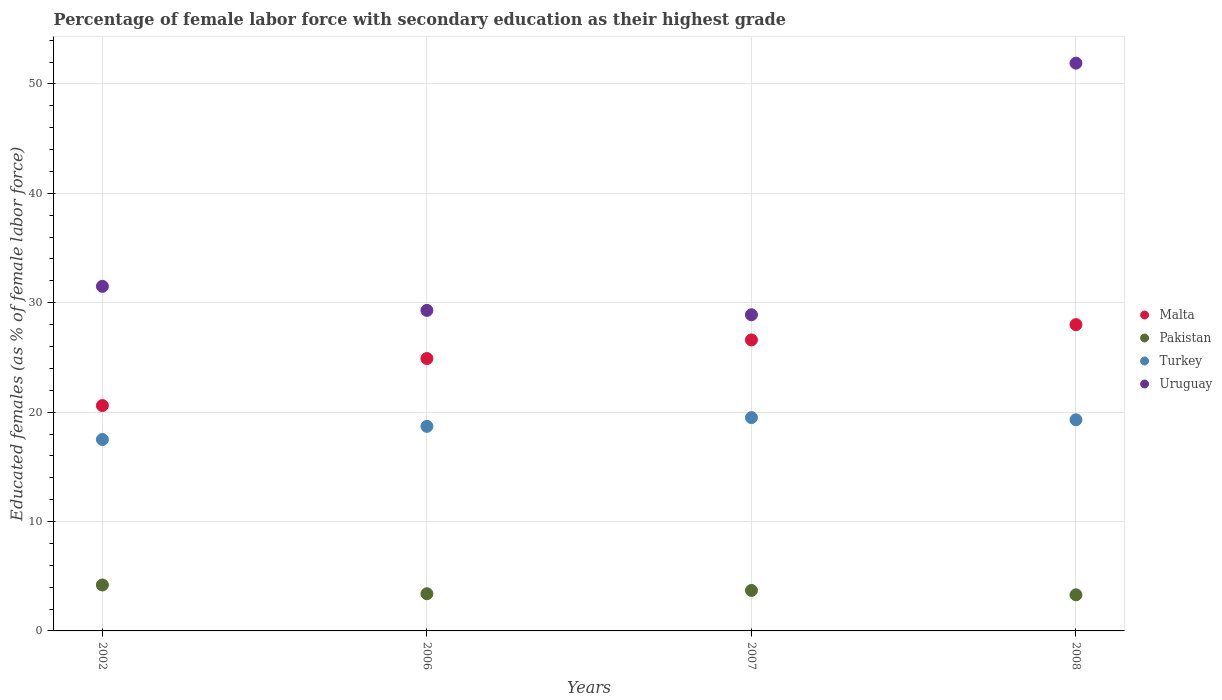How many different coloured dotlines are there?
Your answer should be compact. 4. Is the number of dotlines equal to the number of legend labels?
Provide a short and direct response. Yes. What is the percentage of female labor force with secondary education in Pakistan in 2008?
Provide a short and direct response. 3.3. Across all years, what is the maximum percentage of female labor force with secondary education in Pakistan?
Provide a succinct answer. 4.2. Across all years, what is the minimum percentage of female labor force with secondary education in Uruguay?
Provide a short and direct response. 28.9. In which year was the percentage of female labor force with secondary education in Turkey minimum?
Your answer should be very brief. 2002. What is the total percentage of female labor force with secondary education in Pakistan in the graph?
Your response must be concise. 14.6. What is the difference between the percentage of female labor force with secondary education in Uruguay in 2002 and that in 2007?
Give a very brief answer. 2.6. What is the difference between the percentage of female labor force with secondary education in Malta in 2008 and the percentage of female labor force with secondary education in Turkey in 2007?
Give a very brief answer. 8.5. What is the average percentage of female labor force with secondary education in Malta per year?
Keep it short and to the point. 25.03. In the year 2006, what is the difference between the percentage of female labor force with secondary education in Malta and percentage of female labor force with secondary education in Uruguay?
Provide a succinct answer. -4.4. What is the ratio of the percentage of female labor force with secondary education in Turkey in 2002 to that in 2006?
Keep it short and to the point. 0.94. What is the difference between the highest and the second highest percentage of female labor force with secondary education in Pakistan?
Provide a succinct answer. 0.5. Is the sum of the percentage of female labor force with secondary education in Malta in 2002 and 2006 greater than the maximum percentage of female labor force with secondary education in Uruguay across all years?
Your answer should be very brief. No. Is it the case that in every year, the sum of the percentage of female labor force with secondary education in Turkey and percentage of female labor force with secondary education in Malta  is greater than the sum of percentage of female labor force with secondary education in Pakistan and percentage of female labor force with secondary education in Uruguay?
Ensure brevity in your answer.  No. Is it the case that in every year, the sum of the percentage of female labor force with secondary education in Pakistan and percentage of female labor force with secondary education in Uruguay  is greater than the percentage of female labor force with secondary education in Malta?
Provide a short and direct response. Yes. Does the percentage of female labor force with secondary education in Turkey monotonically increase over the years?
Ensure brevity in your answer.  No. Is the percentage of female labor force with secondary education in Turkey strictly less than the percentage of female labor force with secondary education in Malta over the years?
Make the answer very short. Yes. Does the graph contain any zero values?
Make the answer very short. No. Where does the legend appear in the graph?
Provide a succinct answer. Center right. How many legend labels are there?
Give a very brief answer. 4. How are the legend labels stacked?
Your answer should be very brief. Vertical. What is the title of the graph?
Offer a very short reply. Percentage of female labor force with secondary education as their highest grade. What is the label or title of the Y-axis?
Provide a succinct answer. Educated females (as % of female labor force). What is the Educated females (as % of female labor force) of Malta in 2002?
Your answer should be very brief. 20.6. What is the Educated females (as % of female labor force) in Pakistan in 2002?
Provide a short and direct response. 4.2. What is the Educated females (as % of female labor force) of Uruguay in 2002?
Keep it short and to the point. 31.5. What is the Educated females (as % of female labor force) in Malta in 2006?
Your answer should be compact. 24.9. What is the Educated females (as % of female labor force) in Pakistan in 2006?
Provide a short and direct response. 3.4. What is the Educated females (as % of female labor force) in Turkey in 2006?
Provide a short and direct response. 18.7. What is the Educated females (as % of female labor force) of Uruguay in 2006?
Give a very brief answer. 29.3. What is the Educated females (as % of female labor force) in Malta in 2007?
Your answer should be compact. 26.6. What is the Educated females (as % of female labor force) in Pakistan in 2007?
Give a very brief answer. 3.7. What is the Educated females (as % of female labor force) in Turkey in 2007?
Keep it short and to the point. 19.5. What is the Educated females (as % of female labor force) in Uruguay in 2007?
Make the answer very short. 28.9. What is the Educated females (as % of female labor force) of Pakistan in 2008?
Keep it short and to the point. 3.3. What is the Educated females (as % of female labor force) of Turkey in 2008?
Your response must be concise. 19.3. What is the Educated females (as % of female labor force) of Uruguay in 2008?
Provide a short and direct response. 51.9. Across all years, what is the maximum Educated females (as % of female labor force) of Malta?
Make the answer very short. 28. Across all years, what is the maximum Educated females (as % of female labor force) in Pakistan?
Offer a terse response. 4.2. Across all years, what is the maximum Educated females (as % of female labor force) in Uruguay?
Make the answer very short. 51.9. Across all years, what is the minimum Educated females (as % of female labor force) in Malta?
Your answer should be very brief. 20.6. Across all years, what is the minimum Educated females (as % of female labor force) in Pakistan?
Ensure brevity in your answer.  3.3. Across all years, what is the minimum Educated females (as % of female labor force) in Turkey?
Your answer should be compact. 17.5. Across all years, what is the minimum Educated females (as % of female labor force) of Uruguay?
Your answer should be compact. 28.9. What is the total Educated females (as % of female labor force) of Malta in the graph?
Give a very brief answer. 100.1. What is the total Educated females (as % of female labor force) in Turkey in the graph?
Your answer should be very brief. 75. What is the total Educated females (as % of female labor force) in Uruguay in the graph?
Offer a very short reply. 141.6. What is the difference between the Educated females (as % of female labor force) in Malta in 2002 and that in 2006?
Keep it short and to the point. -4.3. What is the difference between the Educated females (as % of female labor force) of Pakistan in 2002 and that in 2006?
Provide a short and direct response. 0.8. What is the difference between the Educated females (as % of female labor force) of Turkey in 2002 and that in 2006?
Your answer should be compact. -1.2. What is the difference between the Educated females (as % of female labor force) of Uruguay in 2002 and that in 2006?
Your answer should be very brief. 2.2. What is the difference between the Educated females (as % of female labor force) of Pakistan in 2002 and that in 2007?
Your answer should be compact. 0.5. What is the difference between the Educated females (as % of female labor force) of Uruguay in 2002 and that in 2007?
Your response must be concise. 2.6. What is the difference between the Educated females (as % of female labor force) in Malta in 2002 and that in 2008?
Keep it short and to the point. -7.4. What is the difference between the Educated females (as % of female labor force) in Turkey in 2002 and that in 2008?
Offer a very short reply. -1.8. What is the difference between the Educated females (as % of female labor force) of Uruguay in 2002 and that in 2008?
Offer a very short reply. -20.4. What is the difference between the Educated females (as % of female labor force) of Malta in 2006 and that in 2007?
Ensure brevity in your answer.  -1.7. What is the difference between the Educated females (as % of female labor force) of Pakistan in 2006 and that in 2007?
Ensure brevity in your answer.  -0.3. What is the difference between the Educated females (as % of female labor force) of Uruguay in 2006 and that in 2007?
Offer a very short reply. 0.4. What is the difference between the Educated females (as % of female labor force) in Malta in 2006 and that in 2008?
Keep it short and to the point. -3.1. What is the difference between the Educated females (as % of female labor force) in Turkey in 2006 and that in 2008?
Provide a short and direct response. -0.6. What is the difference between the Educated females (as % of female labor force) of Uruguay in 2006 and that in 2008?
Make the answer very short. -22.6. What is the difference between the Educated females (as % of female labor force) in Malta in 2007 and that in 2008?
Keep it short and to the point. -1.4. What is the difference between the Educated females (as % of female labor force) in Malta in 2002 and the Educated females (as % of female labor force) in Turkey in 2006?
Offer a very short reply. 1.9. What is the difference between the Educated females (as % of female labor force) of Pakistan in 2002 and the Educated females (as % of female labor force) of Uruguay in 2006?
Provide a succinct answer. -25.1. What is the difference between the Educated females (as % of female labor force) in Turkey in 2002 and the Educated females (as % of female labor force) in Uruguay in 2006?
Offer a terse response. -11.8. What is the difference between the Educated females (as % of female labor force) of Malta in 2002 and the Educated females (as % of female labor force) of Pakistan in 2007?
Your response must be concise. 16.9. What is the difference between the Educated females (as % of female labor force) in Pakistan in 2002 and the Educated females (as % of female labor force) in Turkey in 2007?
Your response must be concise. -15.3. What is the difference between the Educated females (as % of female labor force) in Pakistan in 2002 and the Educated females (as % of female labor force) in Uruguay in 2007?
Offer a very short reply. -24.7. What is the difference between the Educated females (as % of female labor force) in Turkey in 2002 and the Educated females (as % of female labor force) in Uruguay in 2007?
Provide a succinct answer. -11.4. What is the difference between the Educated females (as % of female labor force) in Malta in 2002 and the Educated females (as % of female labor force) in Pakistan in 2008?
Your answer should be compact. 17.3. What is the difference between the Educated females (as % of female labor force) of Malta in 2002 and the Educated females (as % of female labor force) of Turkey in 2008?
Keep it short and to the point. 1.3. What is the difference between the Educated females (as % of female labor force) of Malta in 2002 and the Educated females (as % of female labor force) of Uruguay in 2008?
Give a very brief answer. -31.3. What is the difference between the Educated females (as % of female labor force) of Pakistan in 2002 and the Educated females (as % of female labor force) of Turkey in 2008?
Keep it short and to the point. -15.1. What is the difference between the Educated females (as % of female labor force) of Pakistan in 2002 and the Educated females (as % of female labor force) of Uruguay in 2008?
Offer a terse response. -47.7. What is the difference between the Educated females (as % of female labor force) in Turkey in 2002 and the Educated females (as % of female labor force) in Uruguay in 2008?
Offer a terse response. -34.4. What is the difference between the Educated females (as % of female labor force) of Malta in 2006 and the Educated females (as % of female labor force) of Pakistan in 2007?
Offer a terse response. 21.2. What is the difference between the Educated females (as % of female labor force) of Malta in 2006 and the Educated females (as % of female labor force) of Turkey in 2007?
Offer a very short reply. 5.4. What is the difference between the Educated females (as % of female labor force) in Pakistan in 2006 and the Educated females (as % of female labor force) in Turkey in 2007?
Offer a terse response. -16.1. What is the difference between the Educated females (as % of female labor force) of Pakistan in 2006 and the Educated females (as % of female labor force) of Uruguay in 2007?
Offer a terse response. -25.5. What is the difference between the Educated females (as % of female labor force) in Malta in 2006 and the Educated females (as % of female labor force) in Pakistan in 2008?
Offer a terse response. 21.6. What is the difference between the Educated females (as % of female labor force) of Malta in 2006 and the Educated females (as % of female labor force) of Turkey in 2008?
Your answer should be very brief. 5.6. What is the difference between the Educated females (as % of female labor force) of Pakistan in 2006 and the Educated females (as % of female labor force) of Turkey in 2008?
Make the answer very short. -15.9. What is the difference between the Educated females (as % of female labor force) in Pakistan in 2006 and the Educated females (as % of female labor force) in Uruguay in 2008?
Offer a very short reply. -48.5. What is the difference between the Educated females (as % of female labor force) in Turkey in 2006 and the Educated females (as % of female labor force) in Uruguay in 2008?
Make the answer very short. -33.2. What is the difference between the Educated females (as % of female labor force) in Malta in 2007 and the Educated females (as % of female labor force) in Pakistan in 2008?
Provide a short and direct response. 23.3. What is the difference between the Educated females (as % of female labor force) in Malta in 2007 and the Educated females (as % of female labor force) in Uruguay in 2008?
Offer a terse response. -25.3. What is the difference between the Educated females (as % of female labor force) in Pakistan in 2007 and the Educated females (as % of female labor force) in Turkey in 2008?
Provide a succinct answer. -15.6. What is the difference between the Educated females (as % of female labor force) of Pakistan in 2007 and the Educated females (as % of female labor force) of Uruguay in 2008?
Your answer should be compact. -48.2. What is the difference between the Educated females (as % of female labor force) of Turkey in 2007 and the Educated females (as % of female labor force) of Uruguay in 2008?
Your answer should be compact. -32.4. What is the average Educated females (as % of female labor force) in Malta per year?
Your response must be concise. 25.02. What is the average Educated females (as % of female labor force) in Pakistan per year?
Ensure brevity in your answer.  3.65. What is the average Educated females (as % of female labor force) of Turkey per year?
Give a very brief answer. 18.75. What is the average Educated females (as % of female labor force) of Uruguay per year?
Make the answer very short. 35.4. In the year 2002, what is the difference between the Educated females (as % of female labor force) of Pakistan and Educated females (as % of female labor force) of Turkey?
Your answer should be compact. -13.3. In the year 2002, what is the difference between the Educated females (as % of female labor force) of Pakistan and Educated females (as % of female labor force) of Uruguay?
Your answer should be very brief. -27.3. In the year 2002, what is the difference between the Educated females (as % of female labor force) in Turkey and Educated females (as % of female labor force) in Uruguay?
Offer a terse response. -14. In the year 2006, what is the difference between the Educated females (as % of female labor force) of Malta and Educated females (as % of female labor force) of Turkey?
Give a very brief answer. 6.2. In the year 2006, what is the difference between the Educated females (as % of female labor force) of Malta and Educated females (as % of female labor force) of Uruguay?
Give a very brief answer. -4.4. In the year 2006, what is the difference between the Educated females (as % of female labor force) in Pakistan and Educated females (as % of female labor force) in Turkey?
Offer a very short reply. -15.3. In the year 2006, what is the difference between the Educated females (as % of female labor force) of Pakistan and Educated females (as % of female labor force) of Uruguay?
Ensure brevity in your answer.  -25.9. In the year 2007, what is the difference between the Educated females (as % of female labor force) in Malta and Educated females (as % of female labor force) in Pakistan?
Provide a succinct answer. 22.9. In the year 2007, what is the difference between the Educated females (as % of female labor force) of Malta and Educated females (as % of female labor force) of Turkey?
Offer a very short reply. 7.1. In the year 2007, what is the difference between the Educated females (as % of female labor force) of Malta and Educated females (as % of female labor force) of Uruguay?
Keep it short and to the point. -2.3. In the year 2007, what is the difference between the Educated females (as % of female labor force) in Pakistan and Educated females (as % of female labor force) in Turkey?
Provide a succinct answer. -15.8. In the year 2007, what is the difference between the Educated females (as % of female labor force) of Pakistan and Educated females (as % of female labor force) of Uruguay?
Provide a succinct answer. -25.2. In the year 2008, what is the difference between the Educated females (as % of female labor force) of Malta and Educated females (as % of female labor force) of Pakistan?
Give a very brief answer. 24.7. In the year 2008, what is the difference between the Educated females (as % of female labor force) of Malta and Educated females (as % of female labor force) of Uruguay?
Your answer should be very brief. -23.9. In the year 2008, what is the difference between the Educated females (as % of female labor force) of Pakistan and Educated females (as % of female labor force) of Uruguay?
Ensure brevity in your answer.  -48.6. In the year 2008, what is the difference between the Educated females (as % of female labor force) of Turkey and Educated females (as % of female labor force) of Uruguay?
Your response must be concise. -32.6. What is the ratio of the Educated females (as % of female labor force) of Malta in 2002 to that in 2006?
Ensure brevity in your answer.  0.83. What is the ratio of the Educated females (as % of female labor force) of Pakistan in 2002 to that in 2006?
Ensure brevity in your answer.  1.24. What is the ratio of the Educated females (as % of female labor force) in Turkey in 2002 to that in 2006?
Your answer should be compact. 0.94. What is the ratio of the Educated females (as % of female labor force) in Uruguay in 2002 to that in 2006?
Make the answer very short. 1.08. What is the ratio of the Educated females (as % of female labor force) of Malta in 2002 to that in 2007?
Provide a short and direct response. 0.77. What is the ratio of the Educated females (as % of female labor force) in Pakistan in 2002 to that in 2007?
Make the answer very short. 1.14. What is the ratio of the Educated females (as % of female labor force) of Turkey in 2002 to that in 2007?
Offer a very short reply. 0.9. What is the ratio of the Educated females (as % of female labor force) in Uruguay in 2002 to that in 2007?
Your answer should be very brief. 1.09. What is the ratio of the Educated females (as % of female labor force) in Malta in 2002 to that in 2008?
Your response must be concise. 0.74. What is the ratio of the Educated females (as % of female labor force) in Pakistan in 2002 to that in 2008?
Provide a succinct answer. 1.27. What is the ratio of the Educated females (as % of female labor force) of Turkey in 2002 to that in 2008?
Your response must be concise. 0.91. What is the ratio of the Educated females (as % of female labor force) of Uruguay in 2002 to that in 2008?
Your answer should be compact. 0.61. What is the ratio of the Educated females (as % of female labor force) of Malta in 2006 to that in 2007?
Make the answer very short. 0.94. What is the ratio of the Educated females (as % of female labor force) in Pakistan in 2006 to that in 2007?
Give a very brief answer. 0.92. What is the ratio of the Educated females (as % of female labor force) of Turkey in 2006 to that in 2007?
Keep it short and to the point. 0.96. What is the ratio of the Educated females (as % of female labor force) in Uruguay in 2006 to that in 2007?
Keep it short and to the point. 1.01. What is the ratio of the Educated females (as % of female labor force) in Malta in 2006 to that in 2008?
Offer a terse response. 0.89. What is the ratio of the Educated females (as % of female labor force) in Pakistan in 2006 to that in 2008?
Ensure brevity in your answer.  1.03. What is the ratio of the Educated females (as % of female labor force) in Turkey in 2006 to that in 2008?
Offer a very short reply. 0.97. What is the ratio of the Educated females (as % of female labor force) of Uruguay in 2006 to that in 2008?
Make the answer very short. 0.56. What is the ratio of the Educated females (as % of female labor force) in Malta in 2007 to that in 2008?
Your answer should be very brief. 0.95. What is the ratio of the Educated females (as % of female labor force) in Pakistan in 2007 to that in 2008?
Your response must be concise. 1.12. What is the ratio of the Educated females (as % of female labor force) of Turkey in 2007 to that in 2008?
Keep it short and to the point. 1.01. What is the ratio of the Educated females (as % of female labor force) in Uruguay in 2007 to that in 2008?
Offer a very short reply. 0.56. What is the difference between the highest and the second highest Educated females (as % of female labor force) of Malta?
Your response must be concise. 1.4. What is the difference between the highest and the second highest Educated females (as % of female labor force) of Pakistan?
Give a very brief answer. 0.5. What is the difference between the highest and the second highest Educated females (as % of female labor force) in Turkey?
Your answer should be very brief. 0.2. What is the difference between the highest and the second highest Educated females (as % of female labor force) in Uruguay?
Ensure brevity in your answer.  20.4. What is the difference between the highest and the lowest Educated females (as % of female labor force) in Turkey?
Offer a terse response. 2. What is the difference between the highest and the lowest Educated females (as % of female labor force) in Uruguay?
Make the answer very short. 23. 